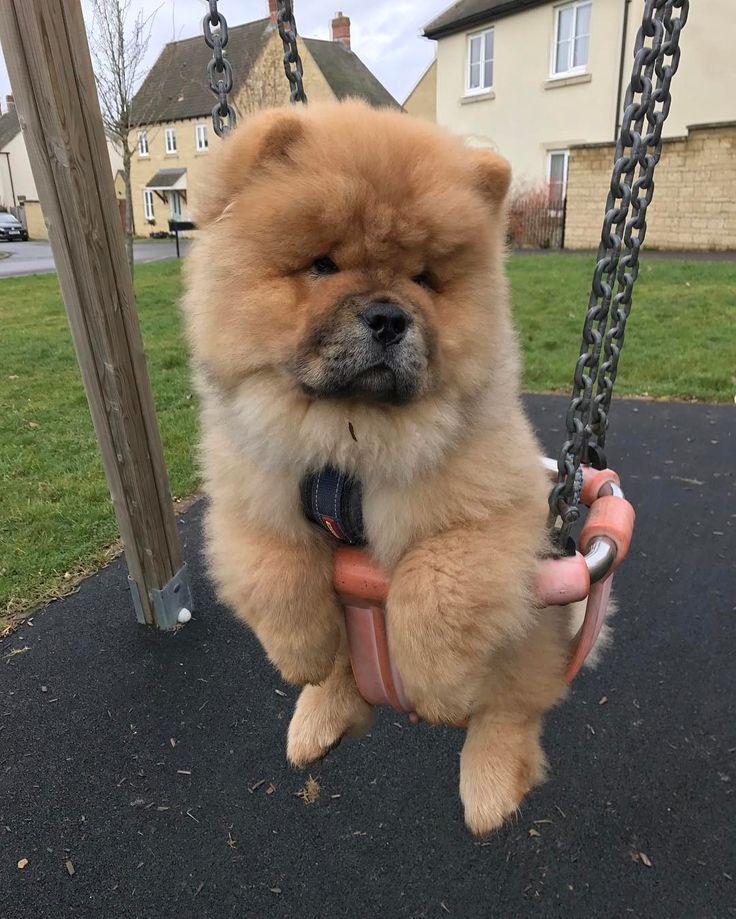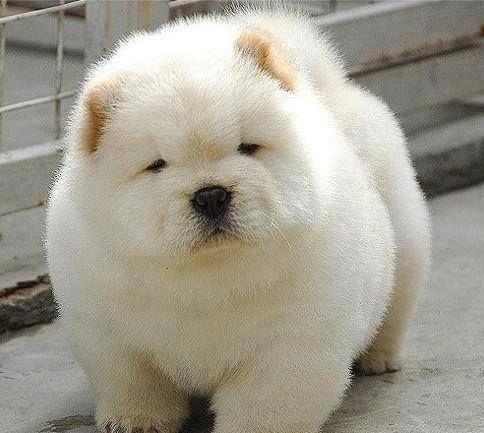The first image is the image on the left, the second image is the image on the right. For the images shown, is this caption "There is at least one human in one of the images." true? Answer yes or no. No. The first image is the image on the left, the second image is the image on the right. Analyze the images presented: Is the assertion "An image shows at least one chow dog in a basket-like container." valid? Answer yes or no. Yes. The first image is the image on the left, the second image is the image on the right. Evaluate the accuracy of this statement regarding the images: "There is one human head in the image on the left.". Is it true? Answer yes or no. No. 